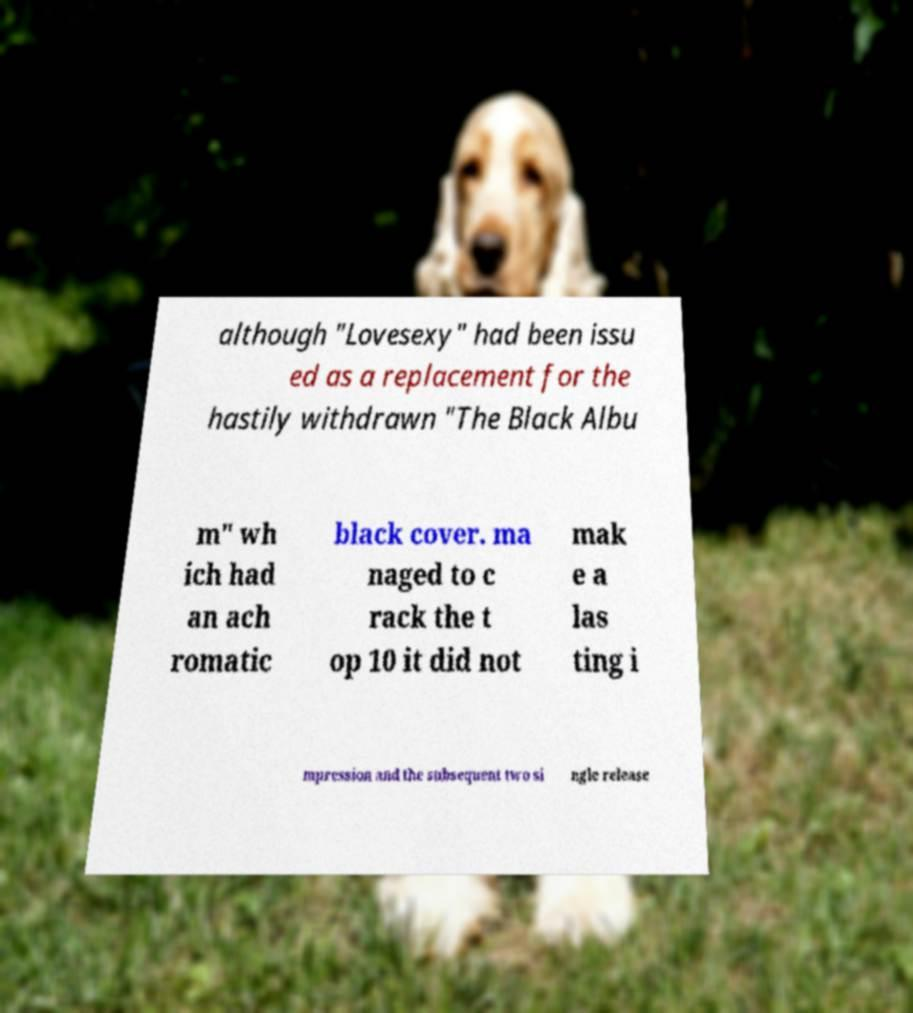Please read and relay the text visible in this image. What does it say? although "Lovesexy" had been issu ed as a replacement for the hastily withdrawn "The Black Albu m" wh ich had an ach romatic black cover. ma naged to c rack the t op 10 it did not mak e a las ting i mpression and the subsequent two si ngle release 